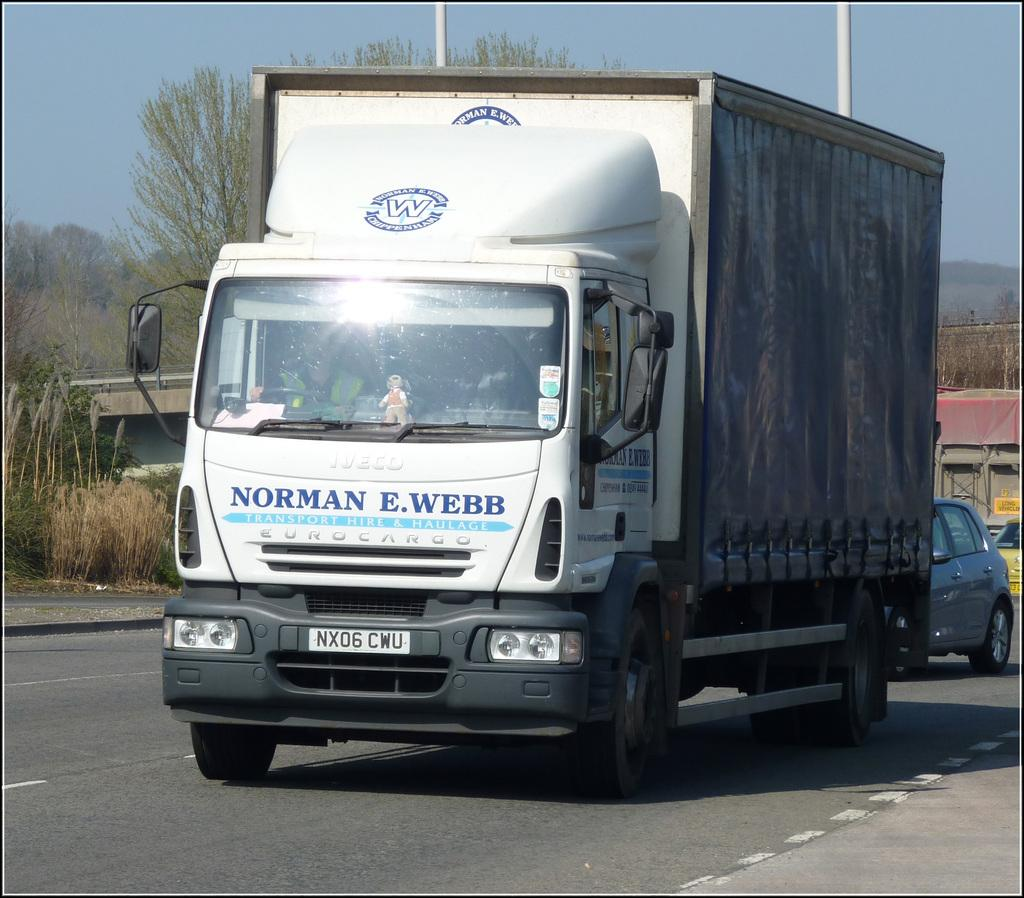What type of vehicle is on the road in the image? There is a truck on the road in the image. Are there any other vehicles in the image? Yes, there are other cars behind the truck in the image. What type of natural elements can be seen in the image? There are trees and plants in the image. Can you describe any other unspecified elements in the image? Unfortunately, the provided facts do not specify the nature of these unspecified elements. What type of chalk is being used to draw on the quiet pies in the image? There is no chalk, quiet pies, or drawing activity present in the image. 